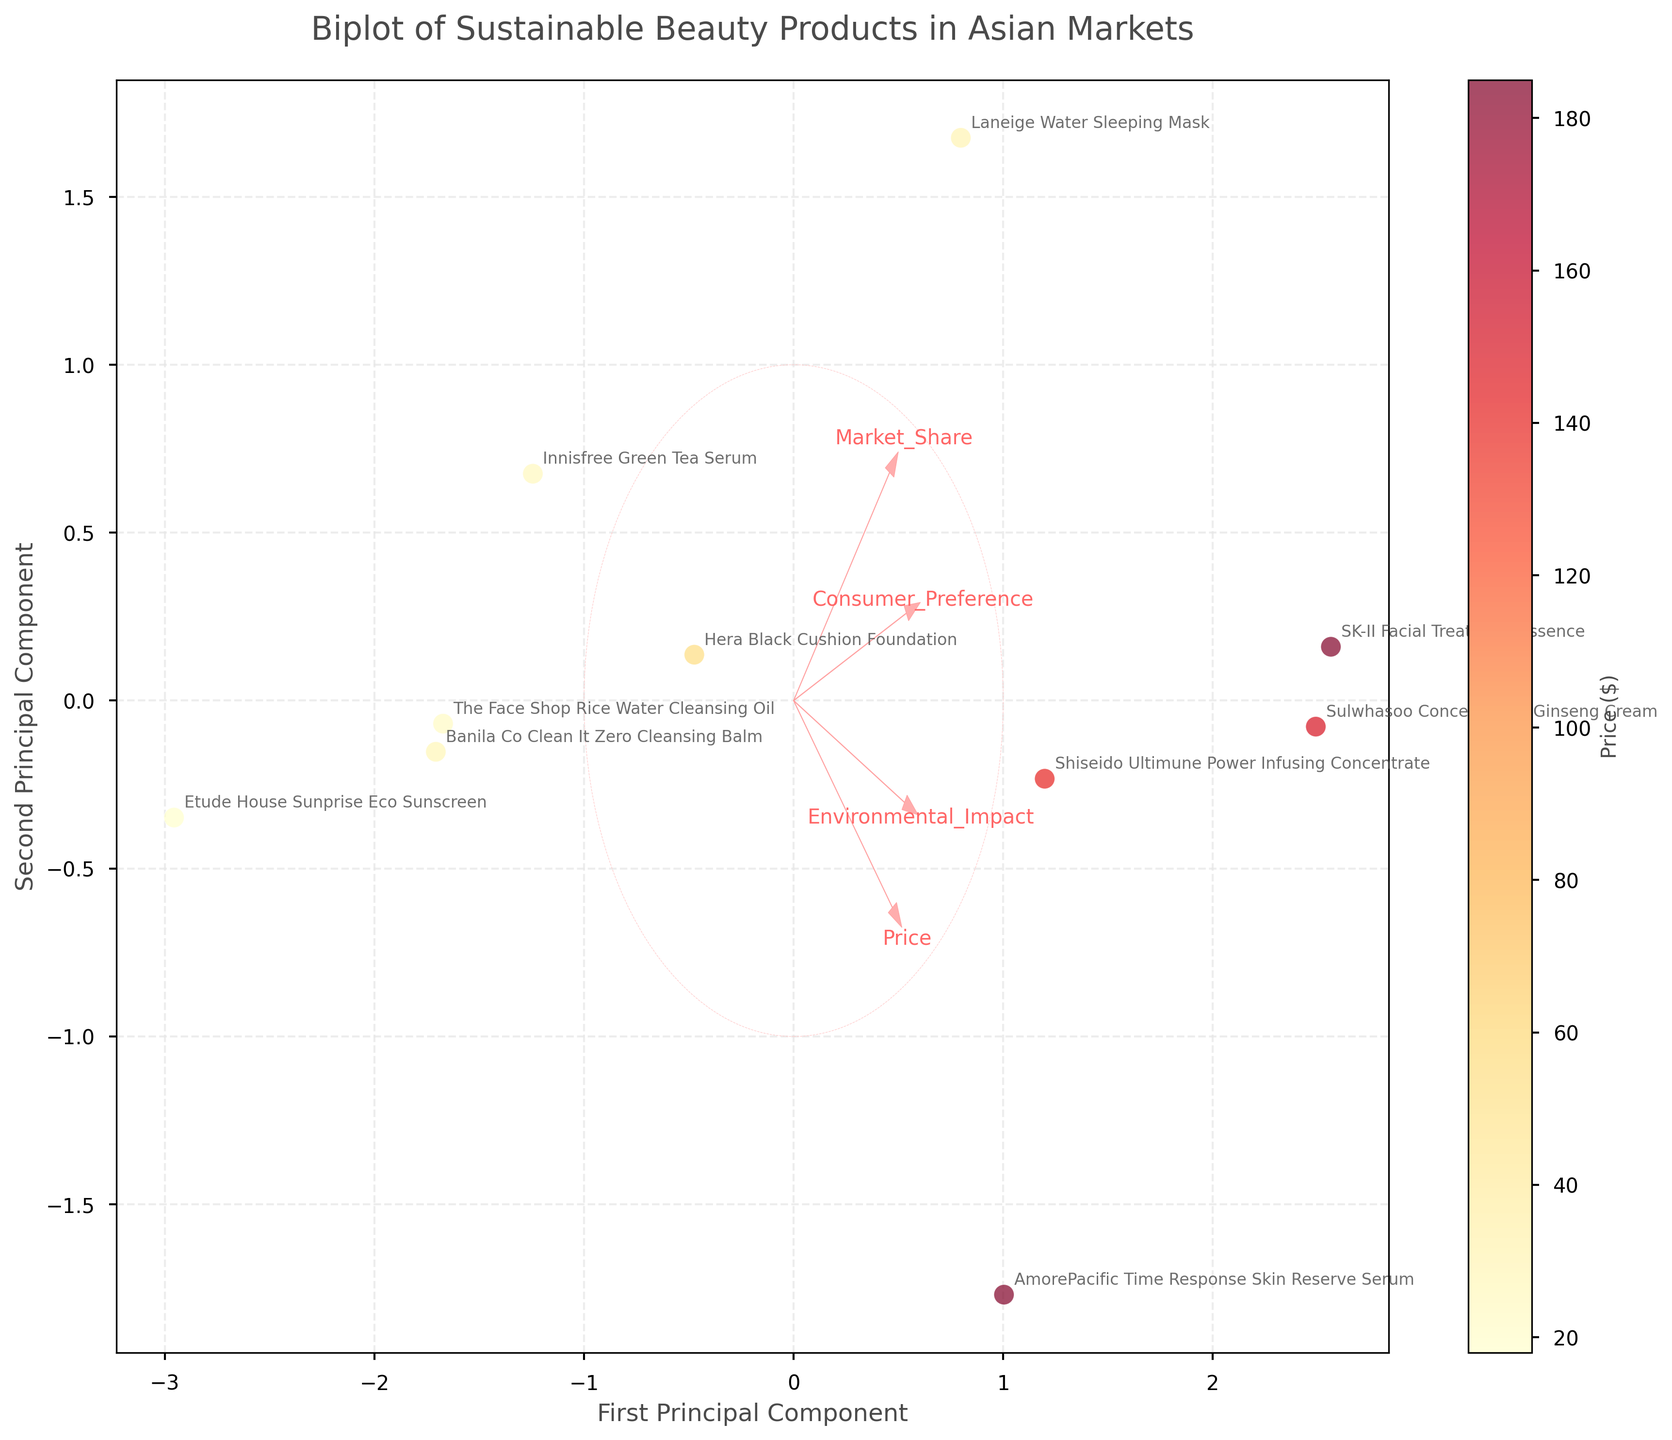What is the title of the biplot? The title can be found at the top of the plot. It is concise and provides an overview of the information being presented.
Answer: Biplot of Sustainable Beauty Products in Asian Markets How many data points are represented in the plot? Data points correspond to the products listed. Counting them will give us the total.
Answer: 10 Which product has the highest price, and what is its value? Locate the color bar for 'Price' and find the darkest shade. Look at the corresponding product label.
Answer: SK-II Facial Treatment Essence, $185 Which product has the lowest environmental impact, and how high is its consumer preference? Trace the coordinates of the data point representing the minimum 'Environmental_Impact' to identify the product. Check the corresponding 'Consumer_Preference' label.
Answer: Etude House Sunprise Eco Sunscreen, 7.9 Compare the consumer preferences of Innisfree Green Tea Serum and Sulwhasoo Concentrated Ginseng Cream. Which one is higher? Find both products on the plot. Compare their vertical coordinates.
Answer: Sulwhasoo Concentrated Ginseng Cream Which feature vector (arrow) points closest to the market share axis? Identify the vectors on the plot. Look for the one most aligned with the horizontal axis corresponding to 'Market_Share.'
Answer: Market_Share How do the prices of Laneige Water Sleeping Mask and Hera Black Cushion Foundation compare? Use the color bar to determine their relative shading intensity and check the annotated prices.
Answer: Laneige Water Sleeping Mask is more expensive What is the trend of consumer preferences for products with high environmental impact vs. low environmental impact? Compare data points with higher 'Environmental_Impact' coordinate values against those with lower values in terms of 'Consumer_Preference.'
Answer: Higher environmental impact products tend to have higher consumer preferences Which feature has the longest vector, and what does it indicate? The length of vectors represents the importance of each feature in the PCA. Identify the longest one.
Answer: Price What is the relationship between 'Market_Share' and the first principal component? Look at how 'Market_Share' vector aligns relative to the first principal component axis.
Answer: Positive relationship 